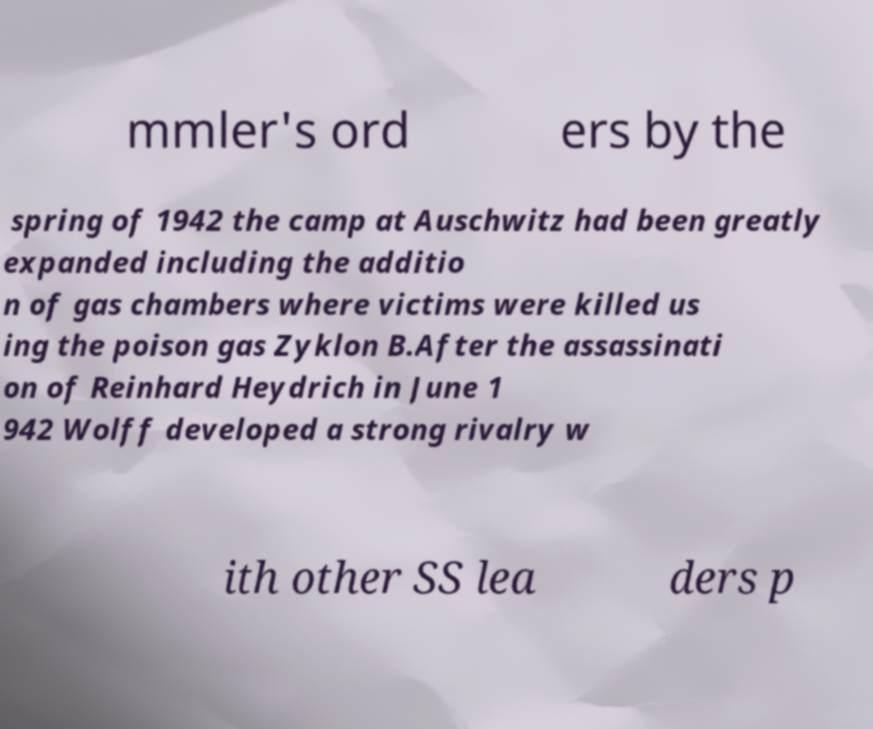Could you extract and type out the text from this image? mmler's ord ers by the spring of 1942 the camp at Auschwitz had been greatly expanded including the additio n of gas chambers where victims were killed us ing the poison gas Zyklon B.After the assassinati on of Reinhard Heydrich in June 1 942 Wolff developed a strong rivalry w ith other SS lea ders p 